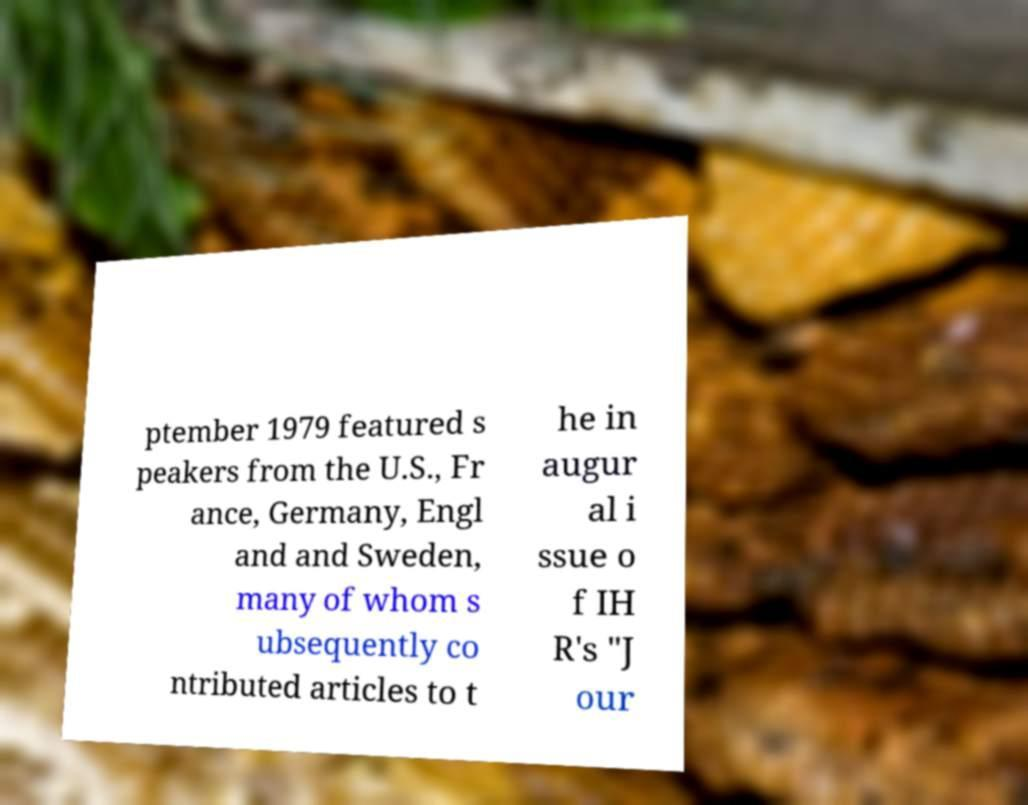For documentation purposes, I need the text within this image transcribed. Could you provide that? ptember 1979 featured s peakers from the U.S., Fr ance, Germany, Engl and and Sweden, many of whom s ubsequently co ntributed articles to t he in augur al i ssue o f IH R's "J our 